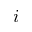<formula> <loc_0><loc_0><loc_500><loc_500>i</formula> 